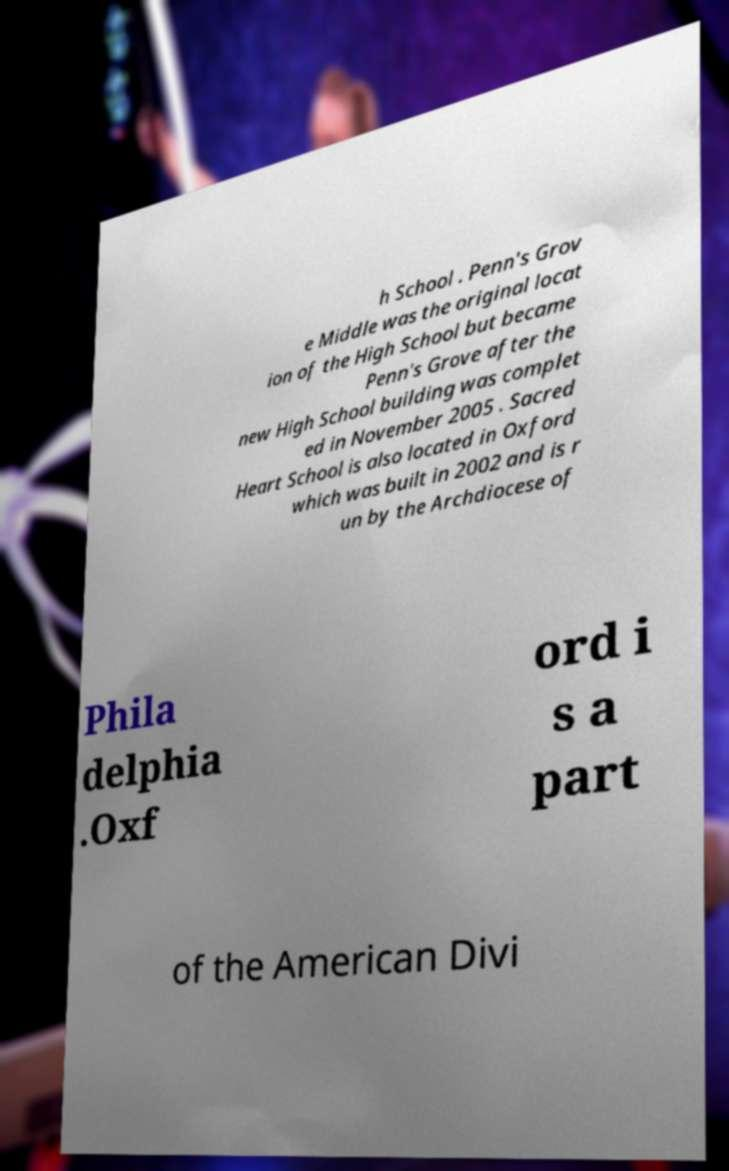There's text embedded in this image that I need extracted. Can you transcribe it verbatim? h School . Penn's Grov e Middle was the original locat ion of the High School but became Penn's Grove after the new High School building was complet ed in November 2005 . Sacred Heart School is also located in Oxford which was built in 2002 and is r un by the Archdiocese of Phila delphia .Oxf ord i s a part of the American Divi 